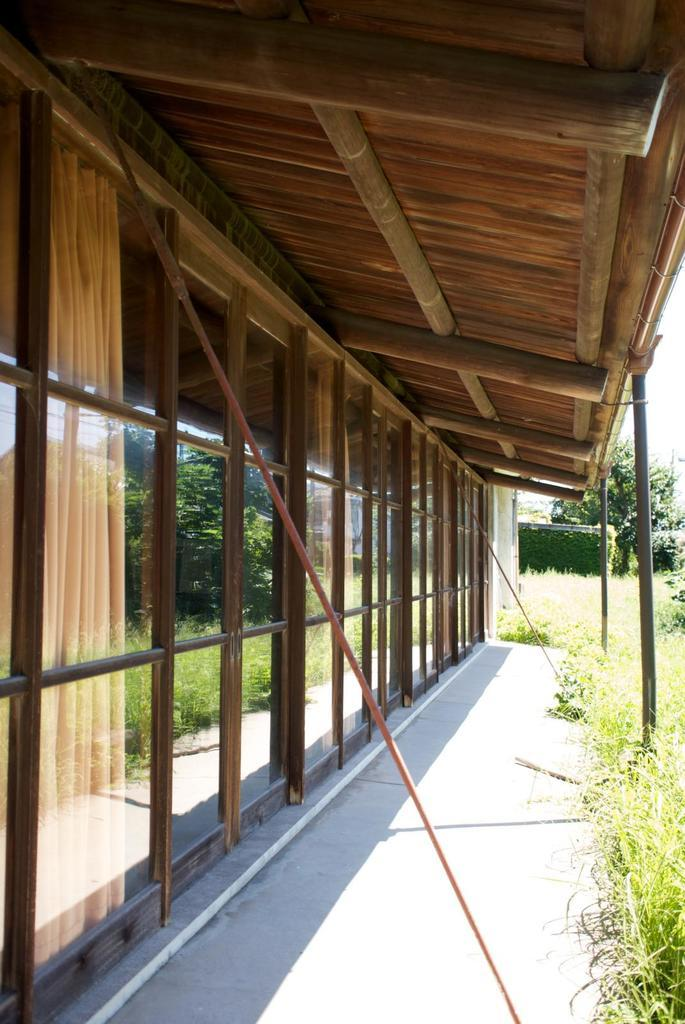What can be seen running through the image? There is a path in the image. What structure is visible at the top of the image? There is a roof visible at the top of the image. What type of wall is present on the left side of the image? There is a glass wall on the left side of the image. What type of vegetation is on the right side of the image? There is grass on the right side of the image. Can you see a laborer carrying a parcel on the path in the image? There is no laborer or parcel present in the image. Is there a monkey climbing the glass wall in the image? There is no monkey present in the image. 